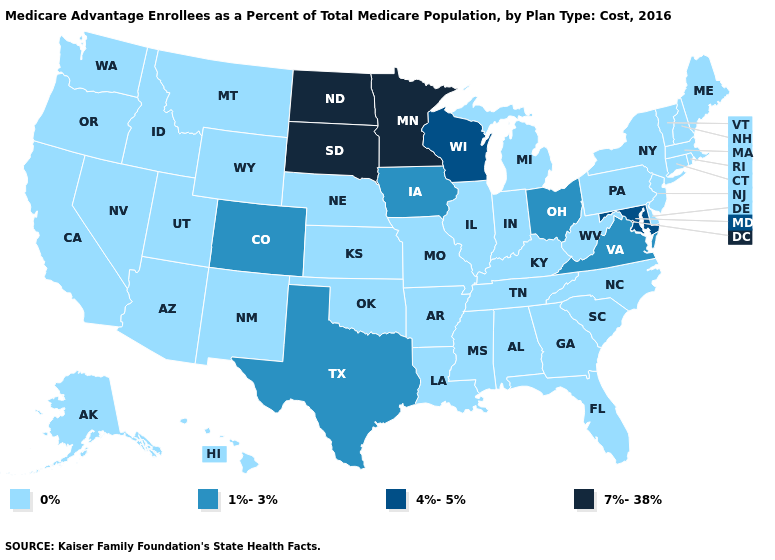Does Wisconsin have the lowest value in the MidWest?
Short answer required. No. Does the map have missing data?
Give a very brief answer. No. What is the value of New Mexico?
Keep it brief. 0%. Name the states that have a value in the range 0%?
Quick response, please. Alaska, Alabama, Arkansas, Arizona, California, Connecticut, Delaware, Florida, Georgia, Hawaii, Idaho, Illinois, Indiana, Kansas, Kentucky, Louisiana, Massachusetts, Maine, Michigan, Missouri, Mississippi, Montana, North Carolina, Nebraska, New Hampshire, New Jersey, New Mexico, Nevada, New York, Oklahoma, Oregon, Pennsylvania, Rhode Island, South Carolina, Tennessee, Utah, Vermont, Washington, West Virginia, Wyoming. What is the lowest value in the USA?
Answer briefly. 0%. Name the states that have a value in the range 0%?
Write a very short answer. Alaska, Alabama, Arkansas, Arizona, California, Connecticut, Delaware, Florida, Georgia, Hawaii, Idaho, Illinois, Indiana, Kansas, Kentucky, Louisiana, Massachusetts, Maine, Michigan, Missouri, Mississippi, Montana, North Carolina, Nebraska, New Hampshire, New Jersey, New Mexico, Nevada, New York, Oklahoma, Oregon, Pennsylvania, Rhode Island, South Carolina, Tennessee, Utah, Vermont, Washington, West Virginia, Wyoming. Does Maryland have the highest value in the South?
Short answer required. Yes. What is the value of Maryland?
Be succinct. 4%-5%. Name the states that have a value in the range 1%-3%?
Write a very short answer. Colorado, Iowa, Ohio, Texas, Virginia. Is the legend a continuous bar?
Quick response, please. No. Which states have the lowest value in the West?
Quick response, please. Alaska, Arizona, California, Hawaii, Idaho, Montana, New Mexico, Nevada, Oregon, Utah, Washington, Wyoming. What is the highest value in states that border West Virginia?
Be succinct. 4%-5%. Which states hav the highest value in the Northeast?
Answer briefly. Connecticut, Massachusetts, Maine, New Hampshire, New Jersey, New York, Pennsylvania, Rhode Island, Vermont. Does Alaska have the lowest value in the West?
Keep it brief. Yes. 